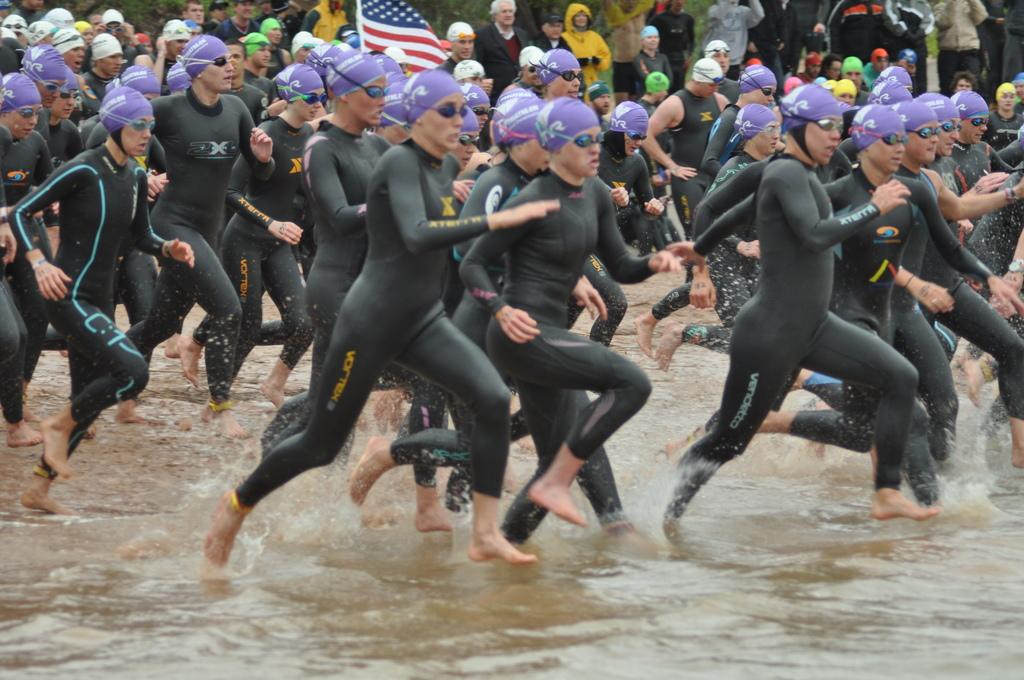What are the persons in the image doing? The persons in the image are running in the water. What type of clothing are the persons wearing? The persons are wearing swimsuits. Can you describe the people in the background? There are persons standing in the background. What can be seen in the background besides the standing persons? There is a flag visible in the background. What type of furniture can be seen in the image? There is no furniture present in the image. 